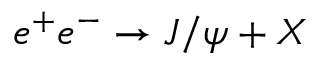Convert formula to latex. <formula><loc_0><loc_0><loc_500><loc_500>e ^ { + } e ^ { - } \to J / \psi + X</formula> 